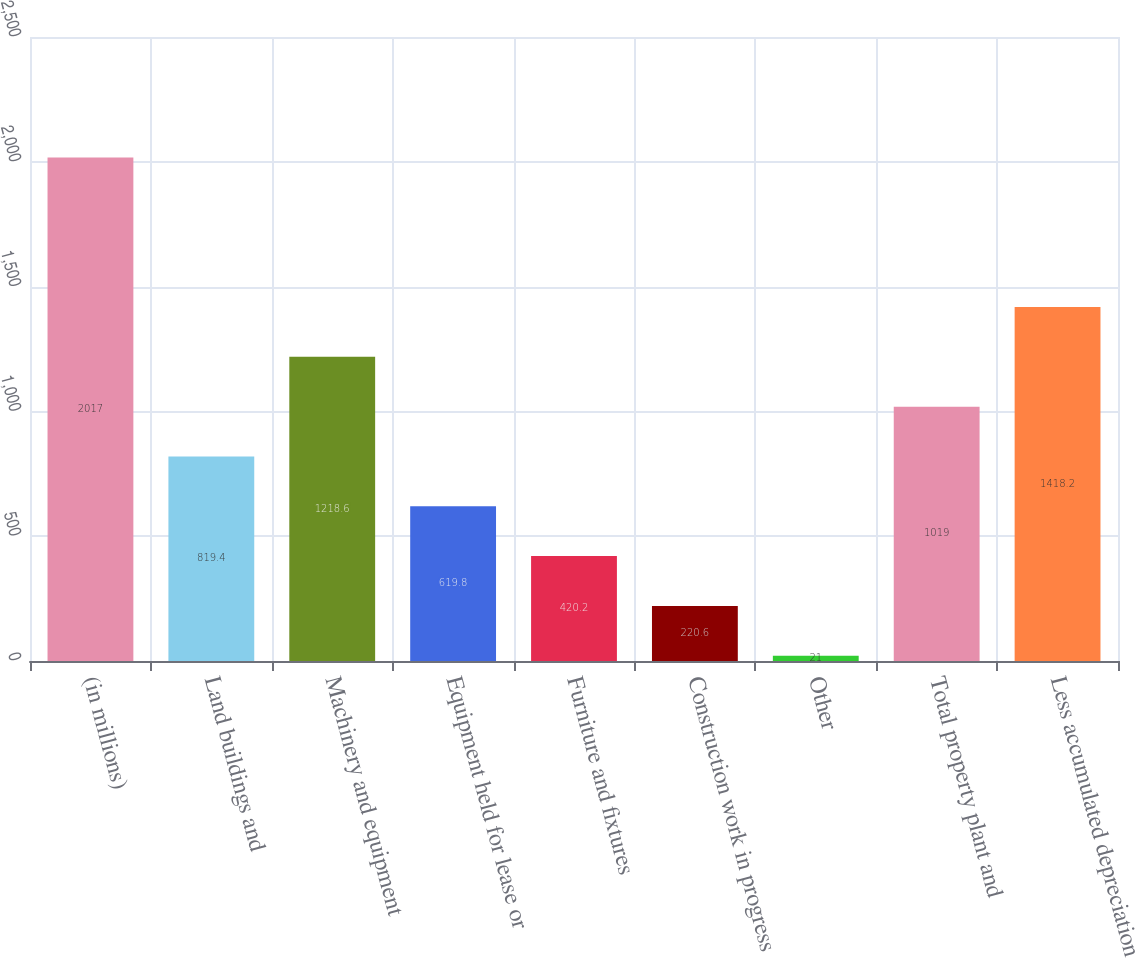Convert chart to OTSL. <chart><loc_0><loc_0><loc_500><loc_500><bar_chart><fcel>(in millions)<fcel>Land buildings and<fcel>Machinery and equipment<fcel>Equipment held for lease or<fcel>Furniture and fixtures<fcel>Construction work in progress<fcel>Other<fcel>Total property plant and<fcel>Less accumulated depreciation<nl><fcel>2017<fcel>819.4<fcel>1218.6<fcel>619.8<fcel>420.2<fcel>220.6<fcel>21<fcel>1019<fcel>1418.2<nl></chart> 